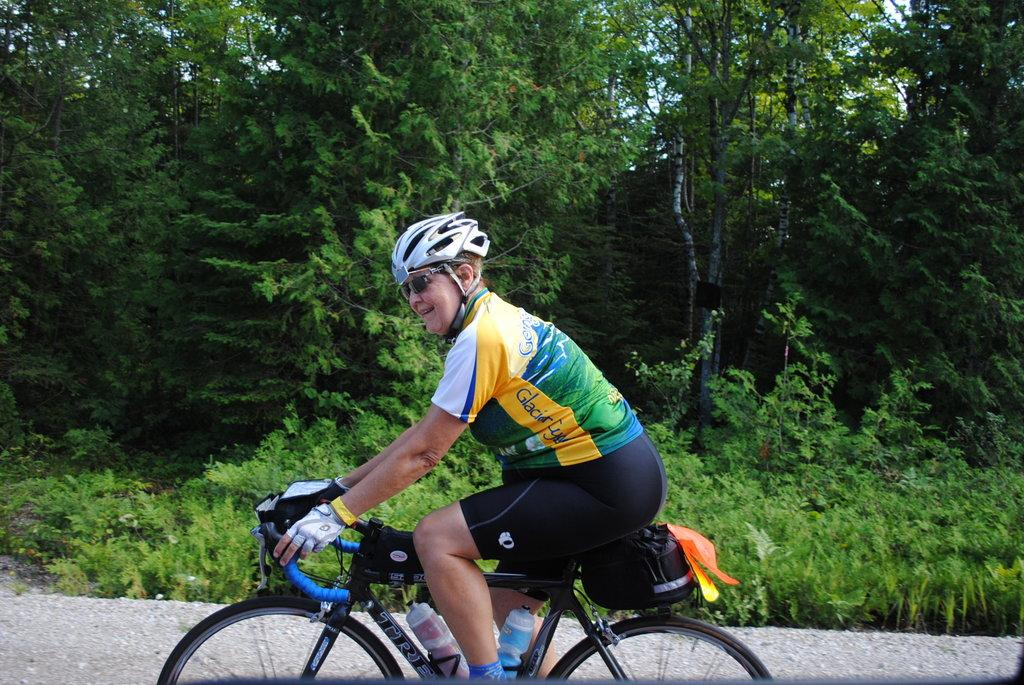What is the main subject of the image? There is a person in the image. What is the person doing in the image? The person is riding a bicycle. How does the person appear to feel in the image? The person is smiling. What can be seen in the background of the image? There are trees in the background of the image. What language is the person speaking in the image? There is no indication of the person speaking in the image, so it cannot be determined what language they might be using. 